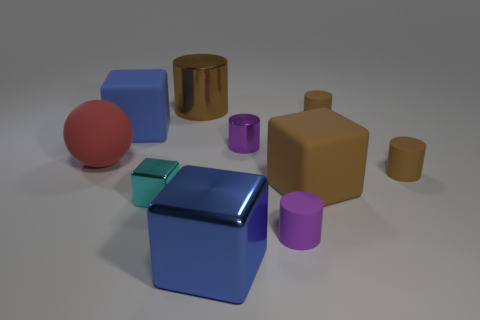How many brown cylinders must be subtracted to get 1 brown cylinders? 2 Subtract all yellow spheres. How many brown cylinders are left? 3 Subtract all large brown shiny cylinders. How many cylinders are left? 4 Subtract 1 cubes. How many cubes are left? 3 Subtract all gray cylinders. Subtract all green cubes. How many cylinders are left? 5 Subtract all blocks. How many objects are left? 6 Subtract all red rubber objects. Subtract all metal cylinders. How many objects are left? 7 Add 8 tiny purple rubber things. How many tiny purple rubber things are left? 9 Add 9 big brown rubber things. How many big brown rubber things exist? 10 Subtract 0 green spheres. How many objects are left? 10 